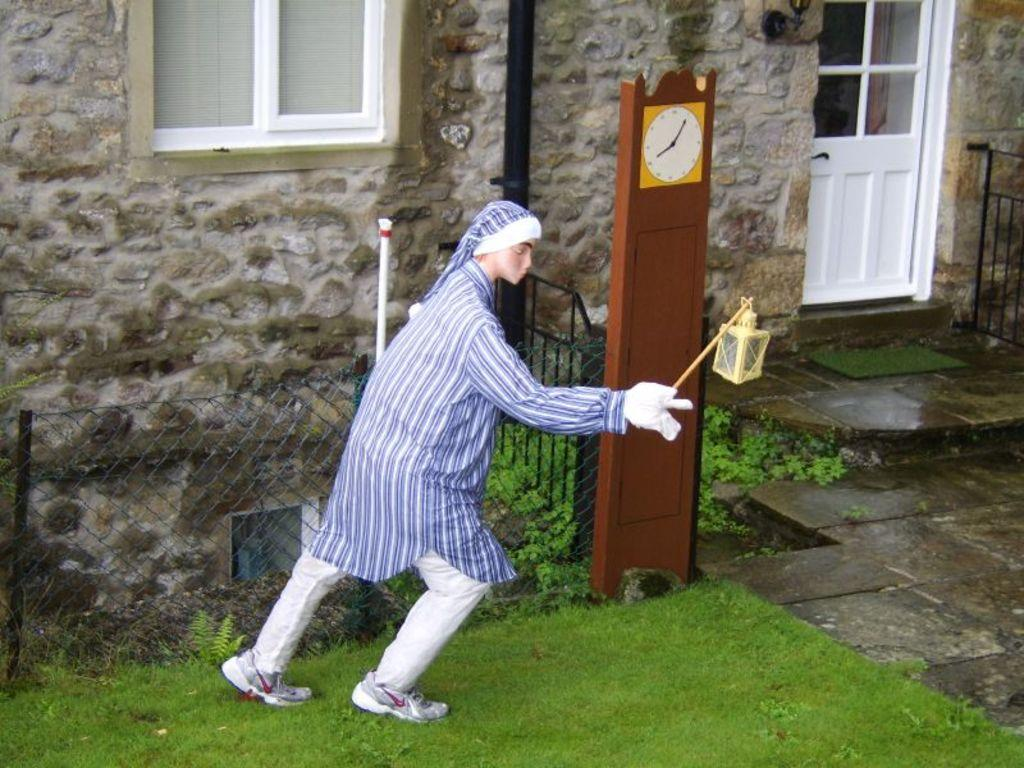What is the main subject in the center of the image? There is a statue in the center of the image. Where is the statue located? The statue is on a grassland. What can be seen in the background of the image? In the background of the image, there is a boundary, a window, a pole, a pipe, a door, and a wooden clock tower. How many mice are sitting on the stove in the image? There is no stove or mice present in the image. What type of body is visible in the image? There is no body present in the image; it features a statue, grassland, and various background elements. 